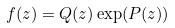Convert formula to latex. <formula><loc_0><loc_0><loc_500><loc_500>f ( z ) = Q ( z ) \exp ( P ( z ) )</formula> 